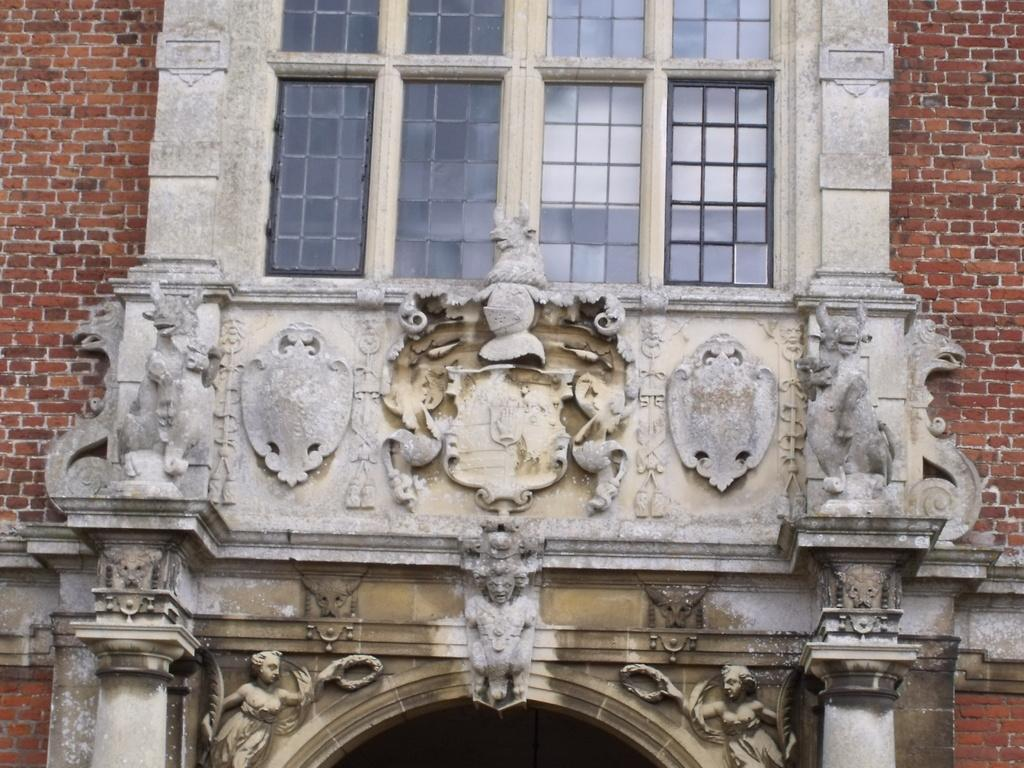What is the main structure visible in the foreground of the image? There is a brick wall in the foreground of the image. Are there any specific features of the brick wall? Yes, the brick wall has an arch. What can be seen on the top side of the image? There is a glass window on the top side of the image. How many dogs are visible in the image? There are no dogs present in the image. What type of lead is used to secure the ghost in the image? There is no ghost or lead present in the image. 